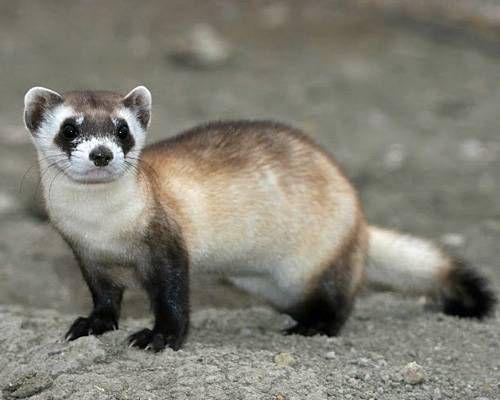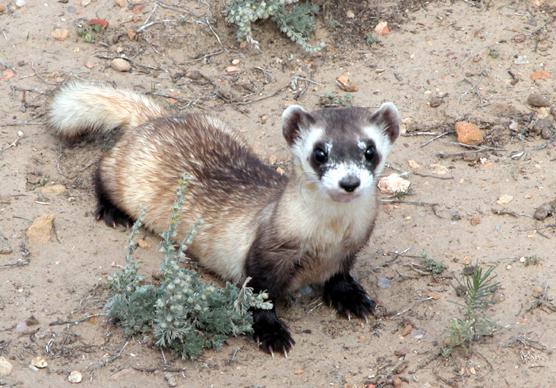The first image is the image on the left, the second image is the image on the right. Analyze the images presented: Is the assertion "The right image contains at least two prairie dogs." valid? Answer yes or no. No. The first image is the image on the left, the second image is the image on the right. Analyze the images presented: Is the assertion "There are exactly two ferrets." valid? Answer yes or no. Yes. 